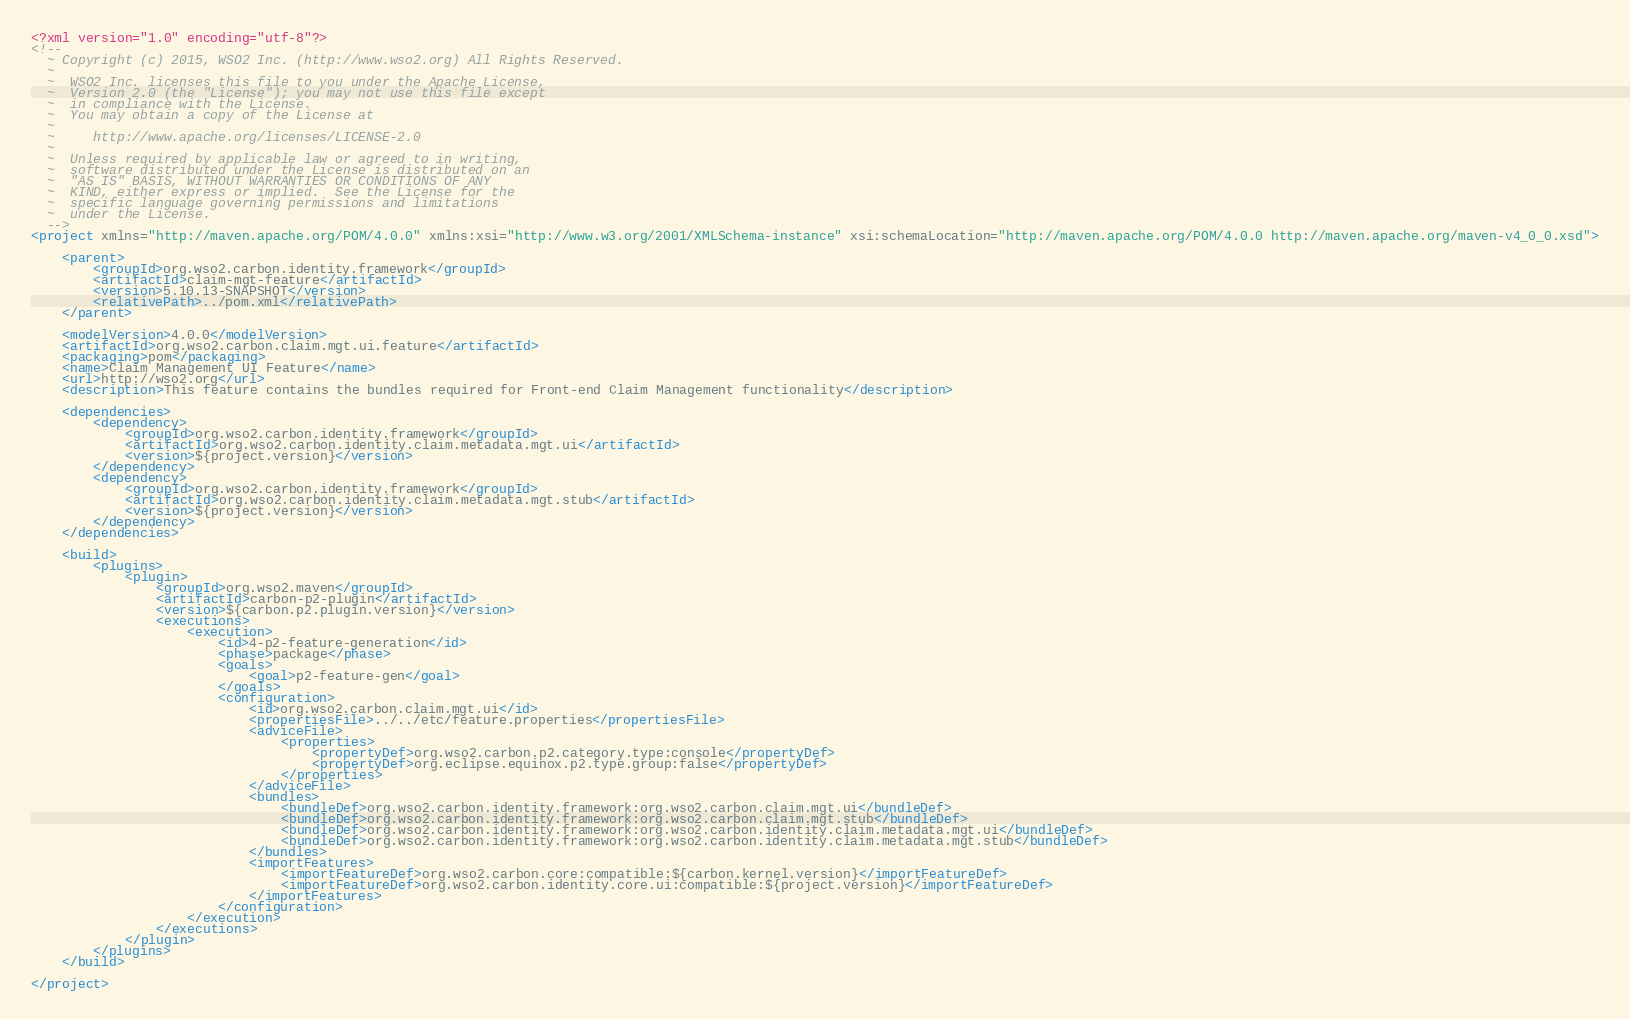<code> <loc_0><loc_0><loc_500><loc_500><_XML_><?xml version="1.0" encoding="utf-8"?>
<!--
  ~ Copyright (c) 2015, WSO2 Inc. (http://www.wso2.org) All Rights Reserved.
  ~
  ~  WSO2 Inc. licenses this file to you under the Apache License,
  ~  Version 2.0 (the "License"); you may not use this file except
  ~  in compliance with the License.
  ~  You may obtain a copy of the License at
  ~
  ~     http://www.apache.org/licenses/LICENSE-2.0
  ~
  ~  Unless required by applicable law or agreed to in writing,
  ~  software distributed under the License is distributed on an
  ~  "AS IS" BASIS, WITHOUT WARRANTIES OR CONDITIONS OF ANY
  ~  KIND, either express or implied.  See the License for the
  ~  specific language governing permissions and limitations
  ~  under the License.
  -->
<project xmlns="http://maven.apache.org/POM/4.0.0" xmlns:xsi="http://www.w3.org/2001/XMLSchema-instance" xsi:schemaLocation="http://maven.apache.org/POM/4.0.0 http://maven.apache.org/maven-v4_0_0.xsd">

    <parent>
        <groupId>org.wso2.carbon.identity.framework</groupId>
        <artifactId>claim-mgt-feature</artifactId>
        <version>5.10.13-SNAPSHOT</version>
        <relativePath>../pom.xml</relativePath>
    </parent>

    <modelVersion>4.0.0</modelVersion>
    <artifactId>org.wso2.carbon.claim.mgt.ui.feature</artifactId>
    <packaging>pom</packaging>
    <name>Claim Management UI Feature</name>
    <url>http://wso2.org</url>
    <description>This feature contains the bundles required for Front-end Claim Management functionality</description>

    <dependencies>
        <dependency>
            <groupId>org.wso2.carbon.identity.framework</groupId>
            <artifactId>org.wso2.carbon.identity.claim.metadata.mgt.ui</artifactId>
            <version>${project.version}</version>
        </dependency>
        <dependency>
            <groupId>org.wso2.carbon.identity.framework</groupId>
            <artifactId>org.wso2.carbon.identity.claim.metadata.mgt.stub</artifactId>
            <version>${project.version}</version>
        </dependency>
    </dependencies>

    <build>
        <plugins>
            <plugin>
                <groupId>org.wso2.maven</groupId>
                <artifactId>carbon-p2-plugin</artifactId>
                <version>${carbon.p2.plugin.version}</version>
                <executions>
                    <execution>
                        <id>4-p2-feature-generation</id>
                        <phase>package</phase>
                        <goals>
                            <goal>p2-feature-gen</goal>
                        </goals>
                        <configuration>
                            <id>org.wso2.carbon.claim.mgt.ui</id>
                            <propertiesFile>../../etc/feature.properties</propertiesFile>
                            <adviceFile>
                                <properties>
                                    <propertyDef>org.wso2.carbon.p2.category.type:console</propertyDef>
                                    <propertyDef>org.eclipse.equinox.p2.type.group:false</propertyDef>
                                </properties>
                            </adviceFile>
                            <bundles>
                                <bundleDef>org.wso2.carbon.identity.framework:org.wso2.carbon.claim.mgt.ui</bundleDef>
                                <bundleDef>org.wso2.carbon.identity.framework:org.wso2.carbon.claim.mgt.stub</bundleDef>
                                <bundleDef>org.wso2.carbon.identity.framework:org.wso2.carbon.identity.claim.metadata.mgt.ui</bundleDef>
                                <bundleDef>org.wso2.carbon.identity.framework:org.wso2.carbon.identity.claim.metadata.mgt.stub</bundleDef>
                            </bundles>
                            <importFeatures>
                                <importFeatureDef>org.wso2.carbon.core:compatible:${carbon.kernel.version}</importFeatureDef>
                                <importFeatureDef>org.wso2.carbon.identity.core.ui:compatible:${project.version}</importFeatureDef>
                            </importFeatures>
                        </configuration>
                    </execution>
                </executions>
            </plugin>
        </plugins>
    </build>
    
</project>
</code> 